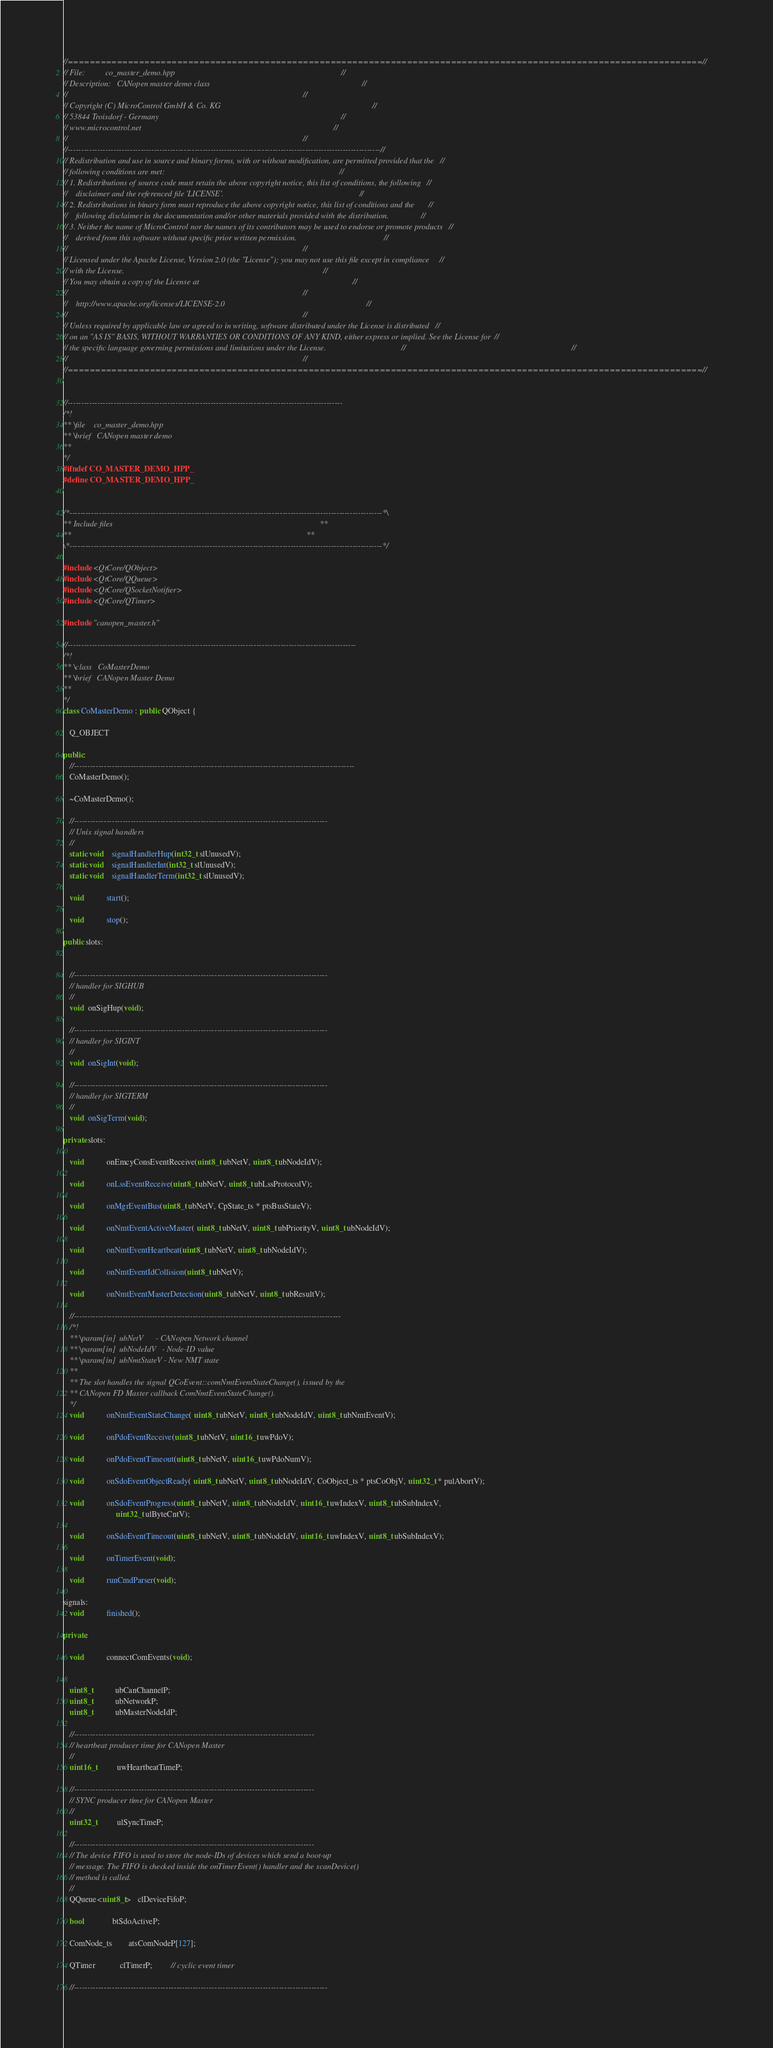<code> <loc_0><loc_0><loc_500><loc_500><_C++_>//====================================================================================================================//
// File:          co_master_demo.hpp                                                                                  //
// Description:   CANopen master demo class                                                                           //
//                                                                                                                    //
// Copyright (C) MicroControl GmbH & Co. KG                                                                           //
// 53844 Troisdorf - Germany                                                                                          //
// www.microcontrol.net                                                                                               //
//                                                                                                                    //
//--------------------------------------------------------------------------------------------------------------------//
// Redistribution and use in source and binary forms, with or without modification, are permitted provided that the   //
// following conditions are met:                                                                                      //
// 1. Redistributions of source code must retain the above copyright notice, this list of conditions, the following   //
//    disclaimer and the referenced file 'LICENSE'.                                                                   //
// 2. Redistributions in binary form must reproduce the above copyright notice, this list of conditions and the       //
//    following disclaimer in the documentation and/or other materials provided with the distribution.                //
// 3. Neither the name of MicroControl nor the names of its contributors may be used to endorse or promote products   //
//    derived from this software without specific prior written permission.                                           //
//                                                                                                                    //
// Licensed under the Apache License, Version 2.0 (the "License"); you may not use this file except in compliance     //
// with the License.                                                                                                  //
// You may obtain a copy of the License at                                                                            //
//                                                                                                                    //
//    http://www.apache.org/licenses/LICENSE-2.0                                                                      //
//                                                                                                                    //
// Unless required by applicable law or agreed to in writing, software distributed under the License is distributed   //
// on an "AS IS" BASIS, WITHOUT WARRANTIES OR CONDITIONS OF ANY KIND, either express or implied. See the License for  //
// the specific language governing permissions and limitations under the License.                                     //                                                                                  //
//                                                                                                                    //
//====================================================================================================================//


//------------------------------------------------------------------------------------------------------
/*!
** \file    co_master_demo.hpp
** \brief   CANopen master demo
**
*/
#ifndef CO_MASTER_DEMO_HPP_
#define CO_MASTER_DEMO_HPP_


/*--------------------------------------------------------------------------------------------------------------------*\
** Include files                                                                                                      **
**                                                                                                                    **
\*--------------------------------------------------------------------------------------------------------------------*/

#include <QtCore/QObject>
#include <QtCore/QQueue>
#include <QtCore/QSocketNotifier>
#include <QtCore/QTimer>

#include "canopen_master.h"

//-----------------------------------------------------------------------------------------------------------
/*!
** \class   CoMasterDemo
** \brief   CANopen Master Demo
**
*/
class CoMasterDemo : public QObject {

   Q_OBJECT

public:
   //--------------------------------------------------------------------------------------------------------
   CoMasterDemo();

   ~CoMasterDemo();

   //----------------------------------------------------------------------------------------------
   // Unix signal handlers
   //
   static void    signalHandlerHup(int32_t slUnusedV);
   static void    signalHandlerInt(int32_t slUnusedV);
   static void    signalHandlerTerm(int32_t slUnusedV);

   void           start();

   void           stop();

public slots:


   //----------------------------------------------------------------------------------------------
   // handler for SIGHUB
   //
   void  onSigHup(void);

   //----------------------------------------------------------------------------------------------
   // handler for SIGINT
   //
   void  onSigInt(void);

   //----------------------------------------------------------------------------------------------
   // handler for SIGTERM
   //
   void  onSigTerm(void);

private slots:

   void           onEmcyConsEventReceive(uint8_t ubNetV, uint8_t ubNodeIdV);

   void           onLssEventReceive(uint8_t ubNetV, uint8_t ubLssProtocolV);

   void           onMgrEventBus(uint8_t ubNetV, CpState_ts * ptsBusStateV);

   void           onNmtEventActiveMaster( uint8_t ubNetV, uint8_t ubPriorityV, uint8_t ubNodeIdV);

   void           onNmtEventHeartbeat(uint8_t ubNetV, uint8_t ubNodeIdV);

   void           onNmtEventIdCollision(uint8_t ubNetV);

   void           onNmtEventMasterDetection(uint8_t ubNetV, uint8_t ubResultV);

   //---------------------------------------------------------------------------------------------------
   /*!
   ** \param[in]  ubNetV      - CANopen Network channel
   ** \param[in]  ubNodeIdV   - Node-ID value
   ** \param[in]  ubNmtStateV - New NMT state
   **
   ** The slot handles the signal QCoEvent::comNmtEventStateChange(), issued by the
   ** CANopen FD Master callback ComNmtEventStateChange().
   */
   void           onNmtEventStateChange( uint8_t ubNetV, uint8_t ubNodeIdV, uint8_t ubNmtEventV);

   void           onPdoEventReceive(uint8_t ubNetV, uint16_t uwPdoV);

   void           onPdoEventTimeout(uint8_t ubNetV, uint16_t uwPdoNumV);

   void           onSdoEventObjectReady( uint8_t ubNetV, uint8_t ubNodeIdV, CoObject_ts * ptsCoObjV, uint32_t * pulAbortV);

   void           onSdoEventProgress(uint8_t ubNetV, uint8_t ubNodeIdV, uint16_t uwIndexV, uint8_t ubSubIndexV,
                          uint32_t ulByteCntV);

   void           onSdoEventTimeout(uint8_t ubNetV, uint8_t ubNodeIdV, uint16_t uwIndexV, uint8_t ubSubIndexV);

   void           onTimerEvent(void);

   void           runCmdParser(void);

signals:
   void           finished();

private:

   void           connectComEvents(void);


   uint8_t           ubCanChannelP;
   uint8_t           ubNetworkP;
   uint8_t           ubMasterNodeIdP;

   //-----------------------------------------------------------------------------------------
   // heartbeat producer time for CANopen Master
   //
   uint16_t          uwHeartbeatTimeP;

   //-----------------------------------------------------------------------------------------
   // SYNC producer time for CANopen Master
   //
   uint32_t          ulSyncTimeP;

   //-----------------------------------------------------------------------------------------
   // The device FIFO is used to store the node-IDs of devices which send a boot-up
   // message. The FIFO is checked inside the onTimerEvent() handler and the scanDevice()
   // method is called.
   //
   QQueue<uint8_t>   clDeviceFifoP;

   bool              btSdoActiveP;

   ComNode_ts        atsComNodeP[127];

   QTimer            clTimerP;         // cyclic event timer
      
   //----------------------------------------------------------------------------------------------</code> 